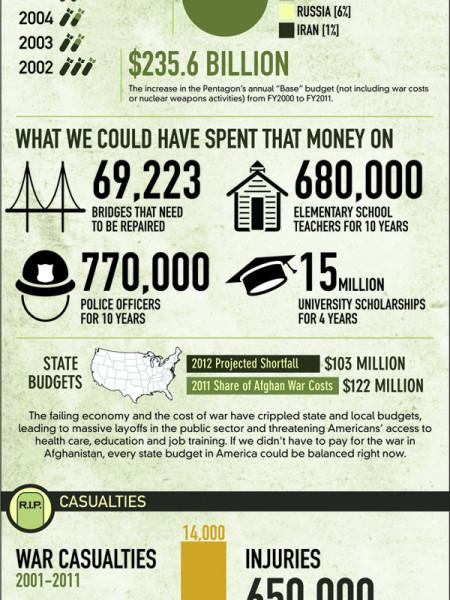Point out several critical features in this image. It is estimated that 680,000 elementary school teachers could have been paid for 10 years. It is estimated that 15 million university scholarships could be awarded over a period of four years. The Pentagon's annual base budget has increased by $235.6 billion. How many more productive and enjoyable ways could $235.6 billion be spent, as listed here? 4 options are suggested. A total of 69,223 bridges required repair. 